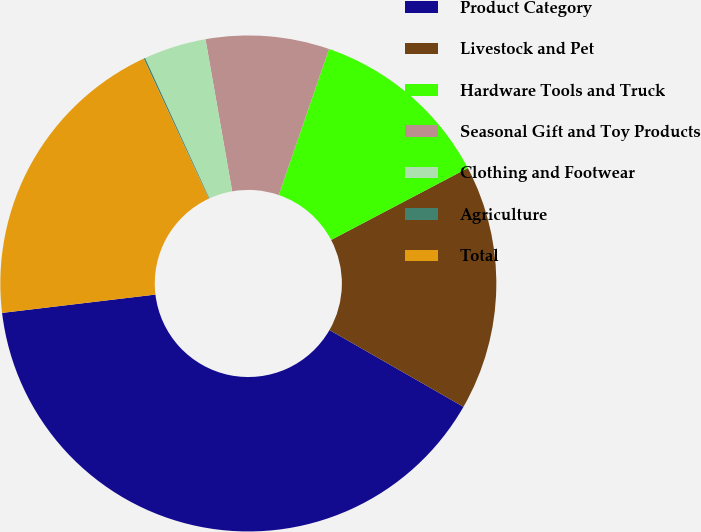<chart> <loc_0><loc_0><loc_500><loc_500><pie_chart><fcel>Product Category<fcel>Livestock and Pet<fcel>Hardware Tools and Truck<fcel>Seasonal Gift and Toy Products<fcel>Clothing and Footwear<fcel>Agriculture<fcel>Total<nl><fcel>39.82%<fcel>15.99%<fcel>12.02%<fcel>8.04%<fcel>4.07%<fcel>0.1%<fcel>19.96%<nl></chart> 